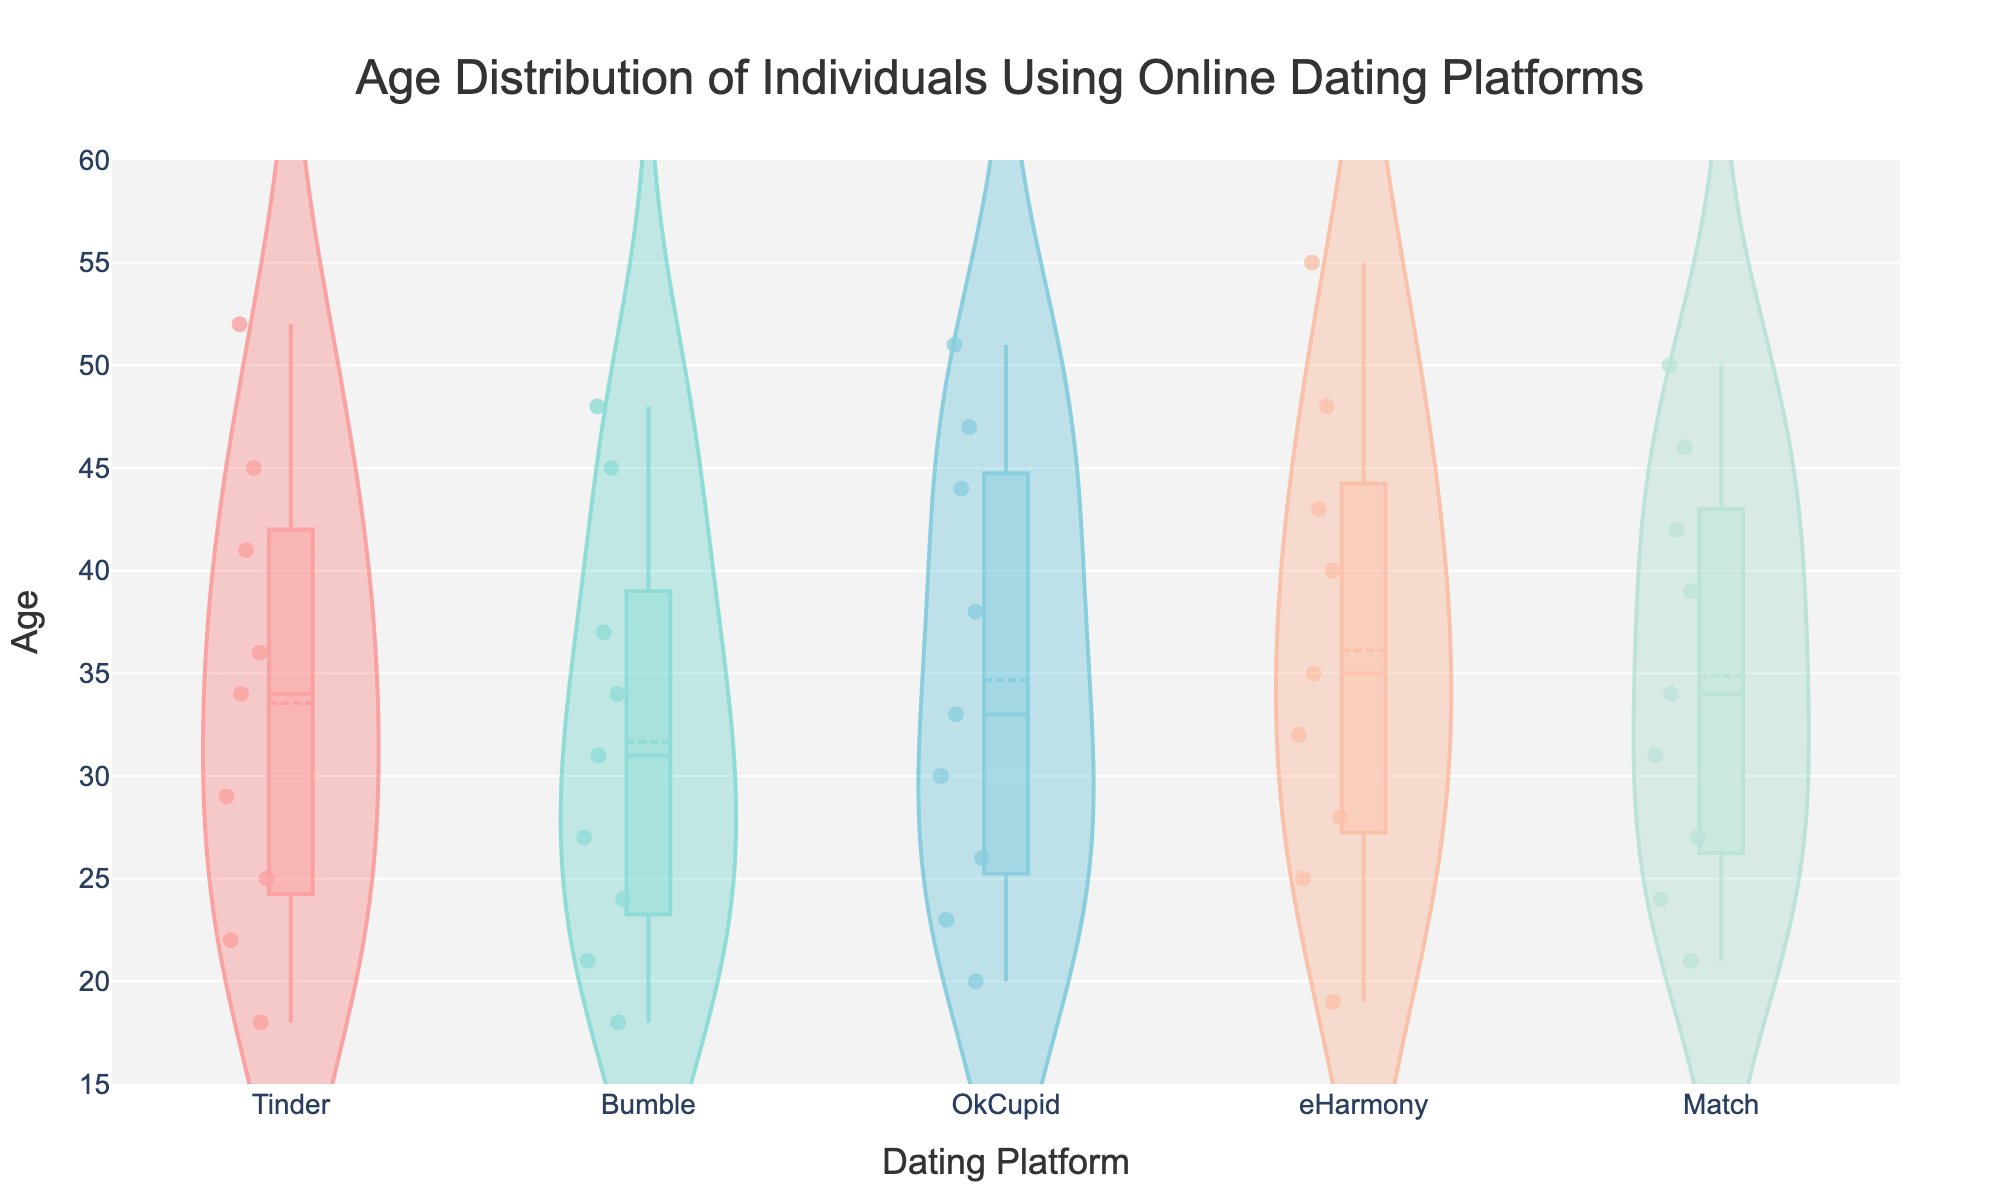What is the title of the figure? The title of the figure is prominently displayed at the top center. It reads "Age Distribution of Individuals Using Online Dating Platforms".
Answer: Age Distribution of Individuals Using Online Dating Platforms How many different dating platforms are shown in the figure? The x-axis of the figure shows labels for the different dating platforms. By counting these labels, we see that there are five platforms: Tinder, Bumble, OkCupid, eHarmony, and Match.
Answer: Five Which dating platform has the widest age range according to the violin plot? To determine which platform has the widest age range, we need to look at the spread of the data along the y-axis for each platform. eHarmony has the widest spread, ranging from 19 to 55.
Answer: eHarmony What is the median age of individuals using Tinder? The box plot overlay on the violin plot provides the median age. For Tinder, the median line within the box plot indicates a median age of around 29.
Answer: 29 Are there any outliers in the age distribution for Bumble? Violin plots with box overlays show outliers as points. For Bumble, we observe no individual data points outside the main data distribution, indicating no outliers.
Answer: No Which dating platform has the highest median age? By comparing the median lines in the box plots for all platforms, we see that eHarmony has the highest median age, around 35.
Answer: eHarmony How do the mean ages of individuals using Tinder and Match compare? The mean line in the box plot assists in finding the mean age. The mean age for Tinder is slightly lower than for Match. By visually comparing, Tinder has a mean around 33, while Match is around 34.
Answer: Match has a higher mean age What’s the interquartile range (IQR) for Match’s age distribution? The interquartile range (IQR) is the difference between the upper and lower quartiles (Q3-Q1) shown in the box. For Match, Q3 is around 42 and Q1 is around 27, so IQR = 42 - 27 = 15.
Answer: 15 Which dating platform has the most concentrated age distribution? A more concentrated distribution means a narrower spread with less variability. By examining the width of the violin plots, we can see that Bumble appears to be the most concentrated with ages primarily in the mid-20s to 40s range.
Answer: Bumble Is there any overlap in the age distributions of OkCupid and eHarmony? Overlapping age distributions can be identified by comparing the spread of the violin plots. Both OkCupid and eHarmony have an overlapping age range from approximately 19 to 51 years.
Answer: Yes 